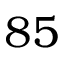Convert formula to latex. <formula><loc_0><loc_0><loc_500><loc_500>8 5</formula> 